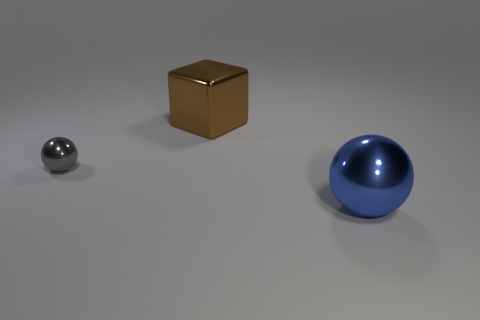Is there anything else that is the same size as the gray object?
Your answer should be very brief. No. What number of other objects are the same size as the gray metal object?
Keep it short and to the point. 0. There is a blue thing that is made of the same material as the block; what size is it?
Your answer should be very brief. Large. Are there fewer cubes than large cyan rubber objects?
Offer a terse response. No. There is a big brown cube; how many small gray metallic spheres are to the left of it?
Give a very brief answer. 1. Is the shape of the small gray metal thing the same as the brown shiny object?
Your response must be concise. No. How many shiny things are in front of the large brown metal cube and to the left of the blue ball?
Provide a succinct answer. 1. How many things are either tiny yellow matte spheres or things right of the gray shiny sphere?
Your answer should be very brief. 2. Are there more tiny purple shiny cubes than tiny gray objects?
Offer a terse response. No. What is the shape of the metallic thing that is to the left of the brown thing?
Your response must be concise. Sphere. 